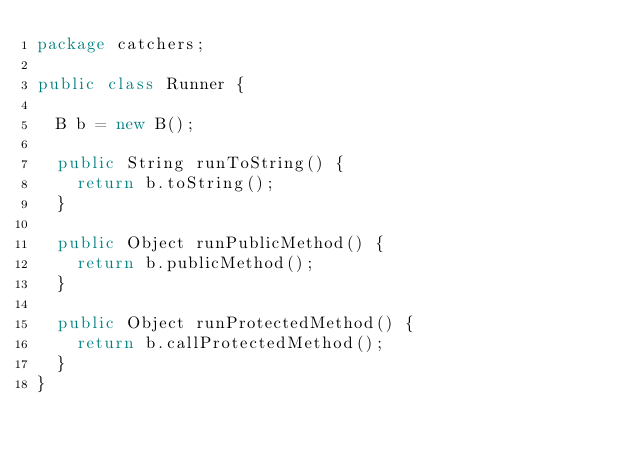Convert code to text. <code><loc_0><loc_0><loc_500><loc_500><_Java_>package catchers;

public class Runner {

	B b = new B();

	public String runToString() {
		return b.toString();
	}

	public Object runPublicMethod() {
		return b.publicMethod();
	}

	public Object runProtectedMethod() {
		return b.callProtectedMethod();
	}
}
</code> 